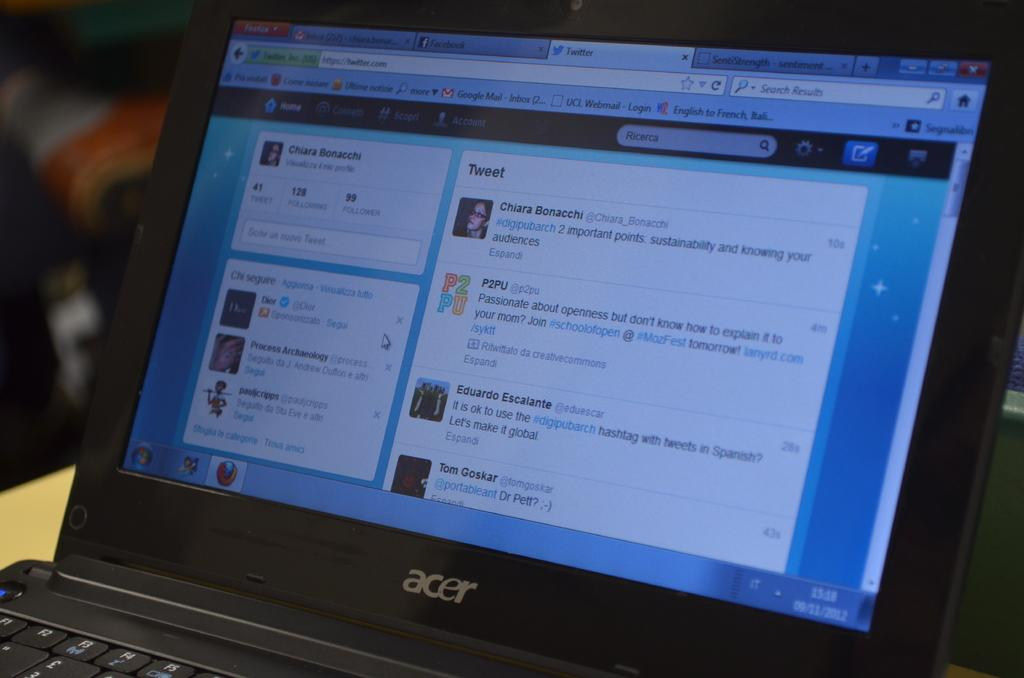<image>
Present a compact description of the photo's key features. laptop screen is opened to a bing web search page 